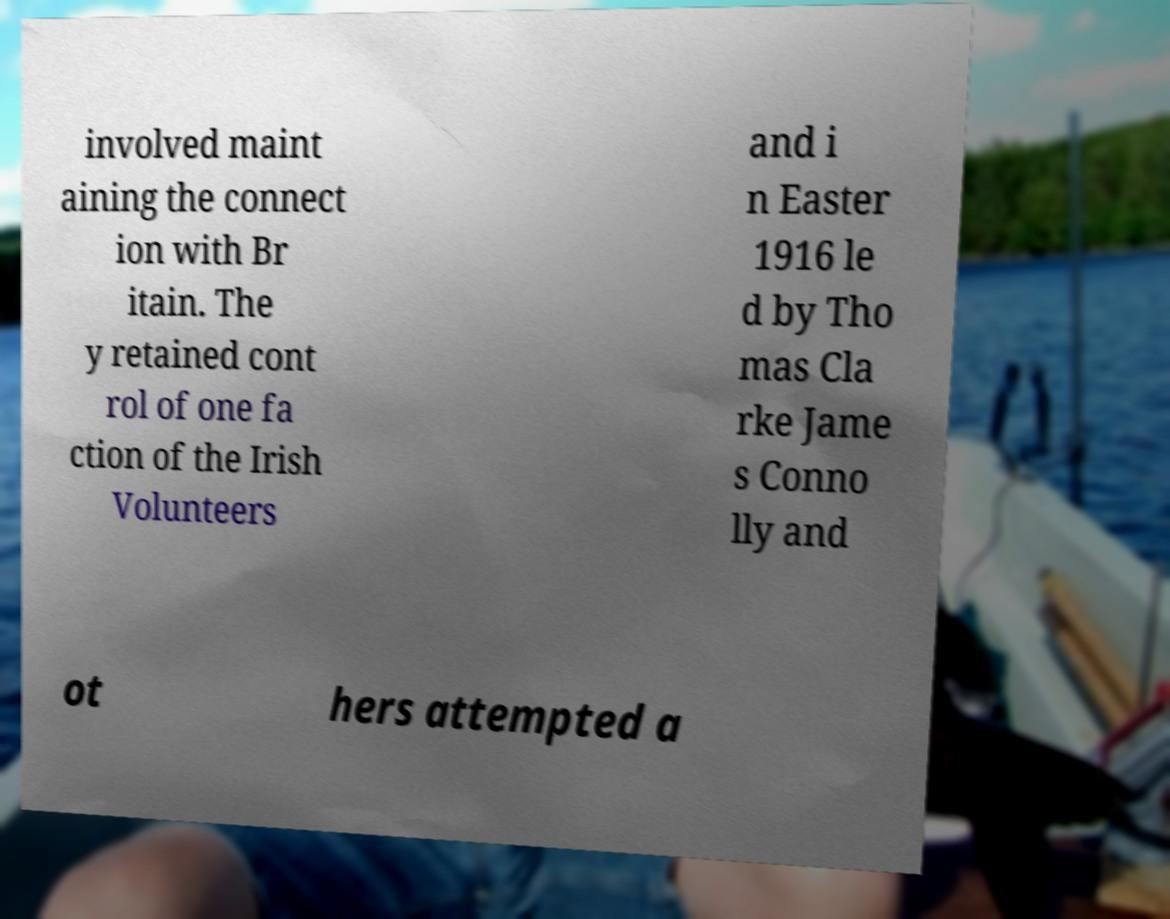Please identify and transcribe the text found in this image. involved maint aining the connect ion with Br itain. The y retained cont rol of one fa ction of the Irish Volunteers and i n Easter 1916 le d by Tho mas Cla rke Jame s Conno lly and ot hers attempted a 